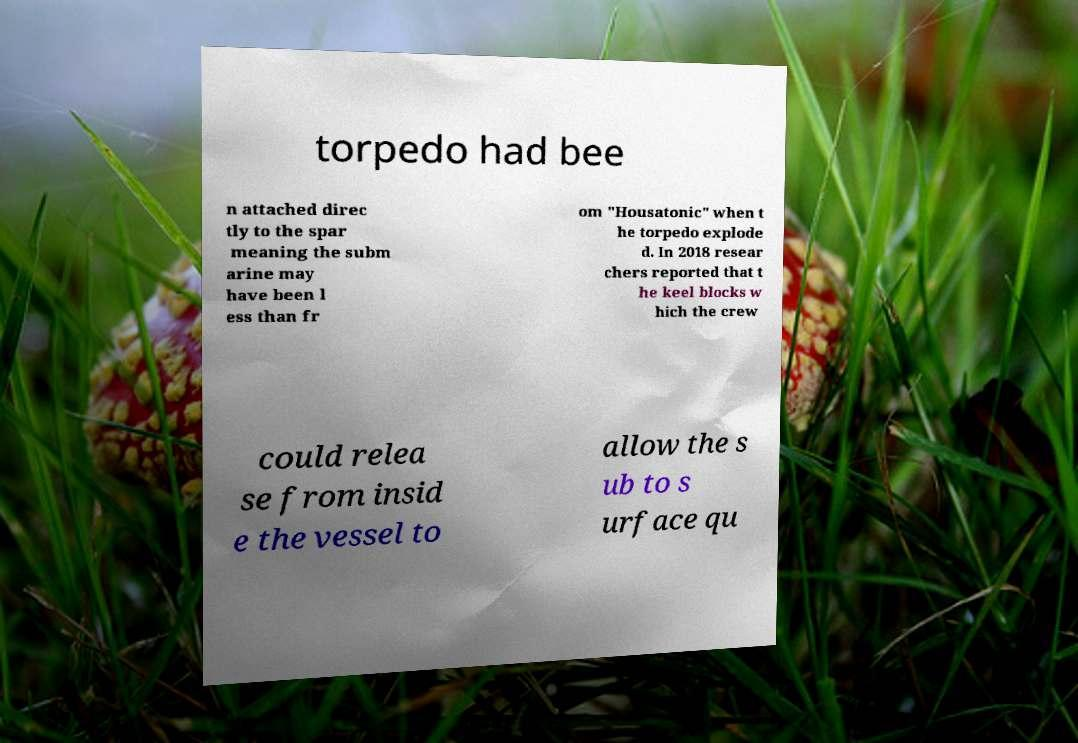For documentation purposes, I need the text within this image transcribed. Could you provide that? torpedo had bee n attached direc tly to the spar meaning the subm arine may have been l ess than fr om "Housatonic" when t he torpedo explode d. In 2018 resear chers reported that t he keel blocks w hich the crew could relea se from insid e the vessel to allow the s ub to s urface qu 